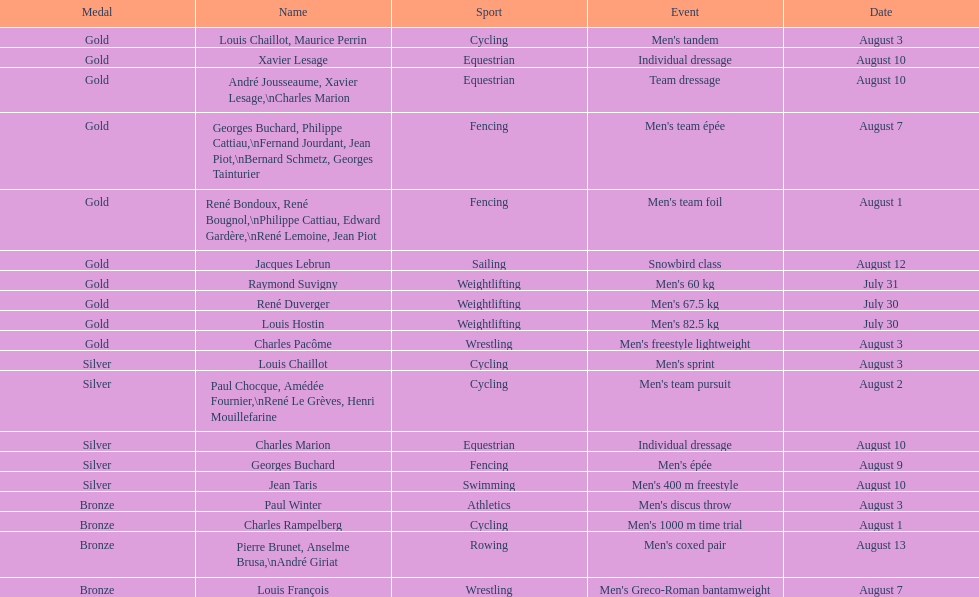Can you give me this table as a dict? {'header': ['Medal', 'Name', 'Sport', 'Event', 'Date'], 'rows': [['Gold', 'Louis Chaillot, Maurice Perrin', 'Cycling', "Men's tandem", 'August 3'], ['Gold', 'Xavier Lesage', 'Equestrian', 'Individual dressage', 'August 10'], ['Gold', 'André Jousseaume, Xavier Lesage,\\nCharles Marion', 'Equestrian', 'Team dressage', 'August 10'], ['Gold', 'Georges Buchard, Philippe Cattiau,\\nFernand Jourdant, Jean Piot,\\nBernard Schmetz, Georges Tainturier', 'Fencing', "Men's team épée", 'August 7'], ['Gold', 'René Bondoux, René Bougnol,\\nPhilippe Cattiau, Edward Gardère,\\nRené Lemoine, Jean Piot', 'Fencing', "Men's team foil", 'August 1'], ['Gold', 'Jacques Lebrun', 'Sailing', 'Snowbird class', 'August 12'], ['Gold', 'Raymond Suvigny', 'Weightlifting', "Men's 60 kg", 'July 31'], ['Gold', 'René Duverger', 'Weightlifting', "Men's 67.5 kg", 'July 30'], ['Gold', 'Louis Hostin', 'Weightlifting', "Men's 82.5 kg", 'July 30'], ['Gold', 'Charles Pacôme', 'Wrestling', "Men's freestyle lightweight", 'August 3'], ['Silver', 'Louis Chaillot', 'Cycling', "Men's sprint", 'August 3'], ['Silver', 'Paul Chocque, Amédée Fournier,\\nRené Le Grèves, Henri Mouillefarine', 'Cycling', "Men's team pursuit", 'August 2'], ['Silver', 'Charles Marion', 'Equestrian', 'Individual dressage', 'August 10'], ['Silver', 'Georges Buchard', 'Fencing', "Men's épée", 'August 9'], ['Silver', 'Jean Taris', 'Swimming', "Men's 400 m freestyle", 'August 10'], ['Bronze', 'Paul Winter', 'Athletics', "Men's discus throw", 'August 3'], ['Bronze', 'Charles Rampelberg', 'Cycling', "Men's 1000 m time trial", 'August 1'], ['Bronze', 'Pierre Brunet, Anselme Brusa,\\nAndré Giriat', 'Rowing', "Men's coxed pair", 'August 13'], ['Bronze', 'Louis François', 'Wrestling', "Men's Greco-Roman bantamweight", 'August 7']]} Was there more gold medals won than silver? Yes. 